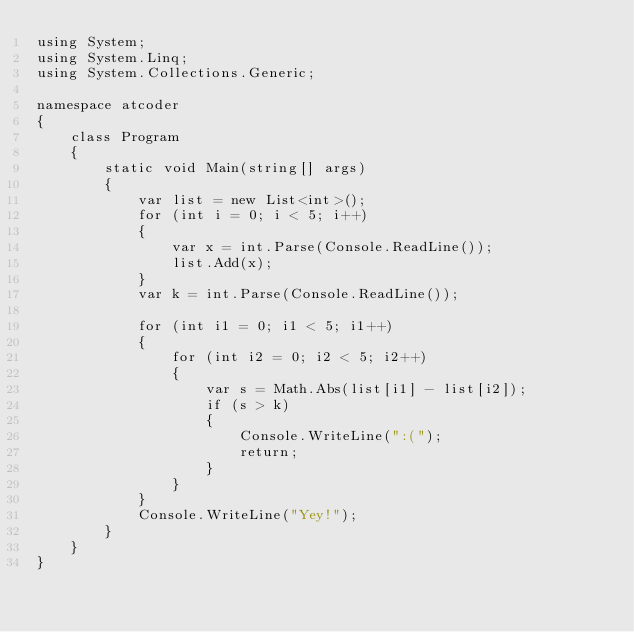Convert code to text. <code><loc_0><loc_0><loc_500><loc_500><_C#_>using System;
using System.Linq;
using System.Collections.Generic;

namespace atcoder
{
    class Program
    {
        static void Main(string[] args)
        {
            var list = new List<int>();
            for (int i = 0; i < 5; i++)
            {
                var x = int.Parse(Console.ReadLine());
                list.Add(x);
            }
            var k = int.Parse(Console.ReadLine());

            for (int i1 = 0; i1 < 5; i1++)
            {
                for (int i2 = 0; i2 < 5; i2++)
                {
                    var s = Math.Abs(list[i1] - list[i2]);
                    if (s > k)
                    {
                        Console.WriteLine(":(");
                        return;
                    }
                }
            }
            Console.WriteLine("Yey!");
        }
    }
}
</code> 